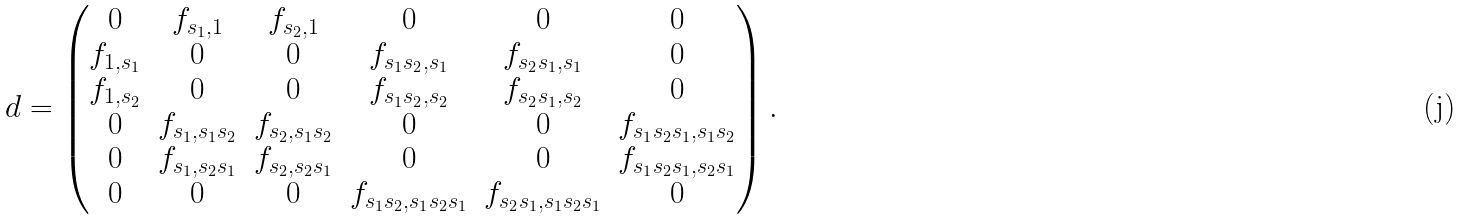<formula> <loc_0><loc_0><loc_500><loc_500>d = \left ( \begin{matrix} 0 & f _ { s _ { 1 } , 1 } & f _ { s _ { 2 } , 1 } & 0 & 0 & 0 \\ f _ { 1 , s _ { 1 } } & 0 & 0 & f _ { s _ { 1 } s _ { 2 } , s _ { 1 } } & f _ { s _ { 2 } s _ { 1 } , s _ { 1 } } & 0 \\ f _ { 1 , s _ { 2 } } & 0 & 0 & f _ { s _ { 1 } s _ { 2 } , s _ { 2 } } & f _ { s _ { 2 } s _ { 1 } , s _ { 2 } } & 0 \\ 0 & f _ { s _ { 1 } , s _ { 1 } s _ { 2 } } & f _ { s _ { 2 } , s _ { 1 } s _ { 2 } } & 0 & 0 & f _ { s _ { 1 } s _ { 2 } s _ { 1 } , s _ { 1 } s _ { 2 } } \\ 0 & f _ { s _ { 1 } , s _ { 2 } s _ { 1 } } & f _ { s _ { 2 } , s _ { 2 } s _ { 1 } } & 0 & 0 & f _ { s _ { 1 } s _ { 2 } s _ { 1 } , s _ { 2 } s _ { 1 } } \\ 0 & 0 & 0 & f _ { s _ { 1 } s _ { 2 } , s _ { 1 } s _ { 2 } s _ { 1 } } & f _ { s _ { 2 } s _ { 1 } , s _ { 1 } s _ { 2 } s _ { 1 } } & 0 \end{matrix} \right ) .</formula> 